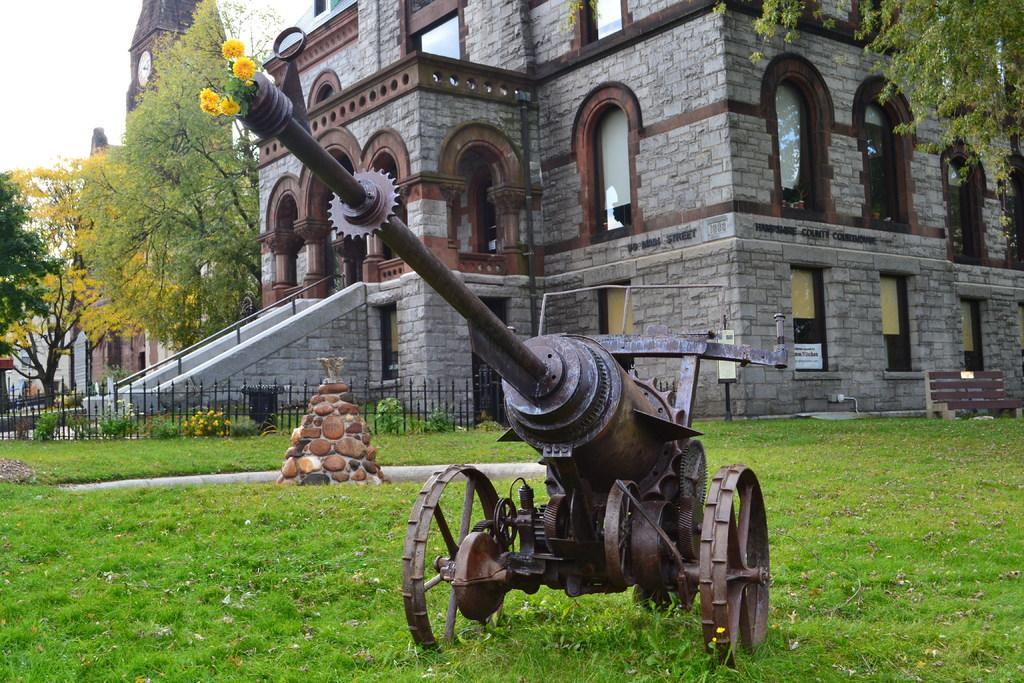How would you summarize this image in a sentence or two? In this image in the background there are some houses and one clock tower and trees and fence and some stairs. In the foreground there is one vehicle, in that vehicle there are some flowers. At the bottom there is grass, and on the right side there is a bench. 